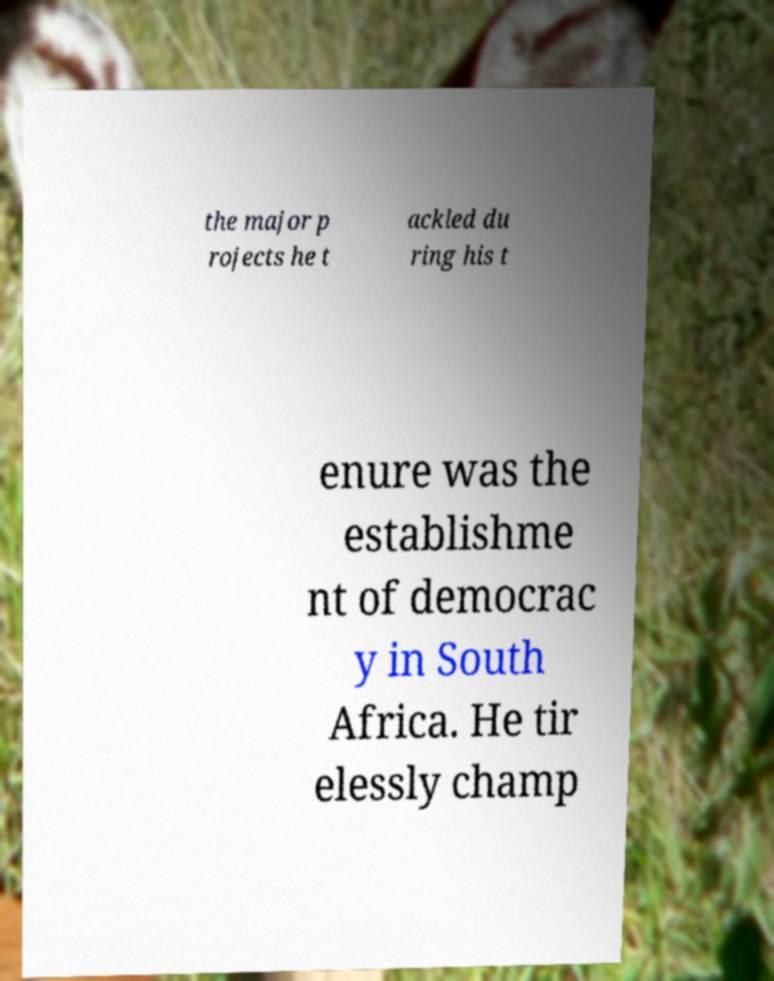I need the written content from this picture converted into text. Can you do that? the major p rojects he t ackled du ring his t enure was the establishme nt of democrac y in South Africa. He tir elessly champ 